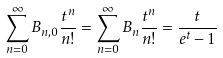Convert formula to latex. <formula><loc_0><loc_0><loc_500><loc_500>\sum _ { n = 0 } ^ { \infty } B _ { n , 0 } \frac { t ^ { n } } { n ! } = \sum _ { n = 0 } ^ { \infty } B _ { n } \frac { t ^ { n } } { n ! } = \frac { t } { e ^ { t } - 1 }</formula> 